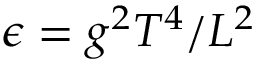Convert formula to latex. <formula><loc_0><loc_0><loc_500><loc_500>\epsilon = g ^ { 2 } T ^ { 4 } / L ^ { 2 }</formula> 